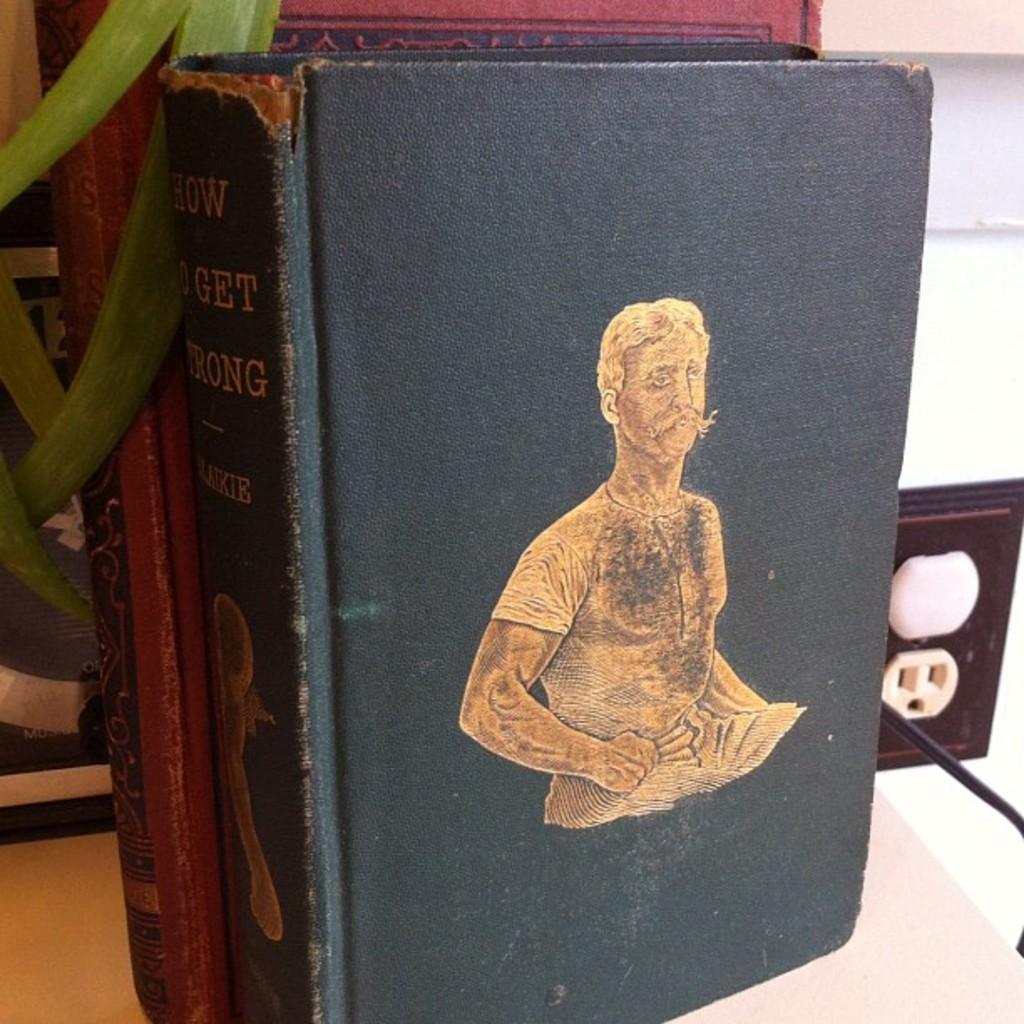What is the name of the book?
Make the answer very short. How to get strong. 